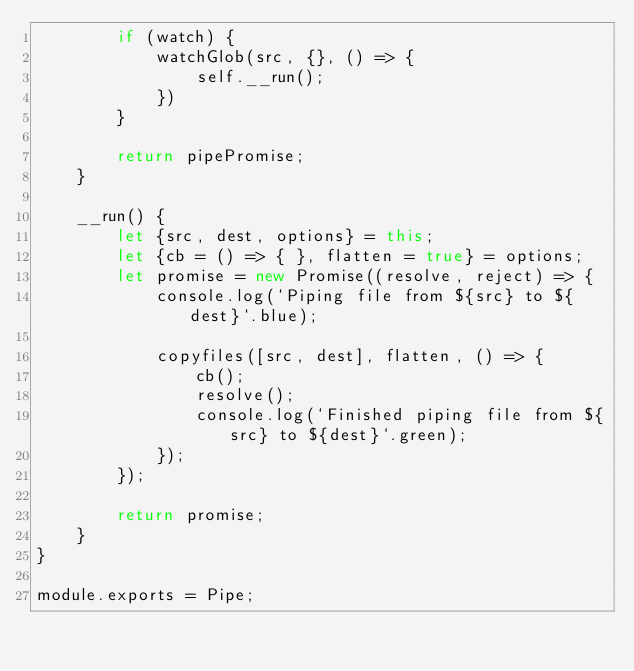<code> <loc_0><loc_0><loc_500><loc_500><_JavaScript_>        if (watch) {
            watchGlob(src, {}, () => {
                self.__run();
            })
        }

        return pipePromise;
    }

    __run() {
        let {src, dest, options} = this;
        let {cb = () => { }, flatten = true} = options;
        let promise = new Promise((resolve, reject) => {
            console.log(`Piping file from ${src} to ${dest}`.blue);

            copyfiles([src, dest], flatten, () => {
                cb();
                resolve();
                console.log(`Finished piping file from ${src} to ${dest}`.green);
            });
        });

        return promise;
    }
}

module.exports = Pipe;</code> 